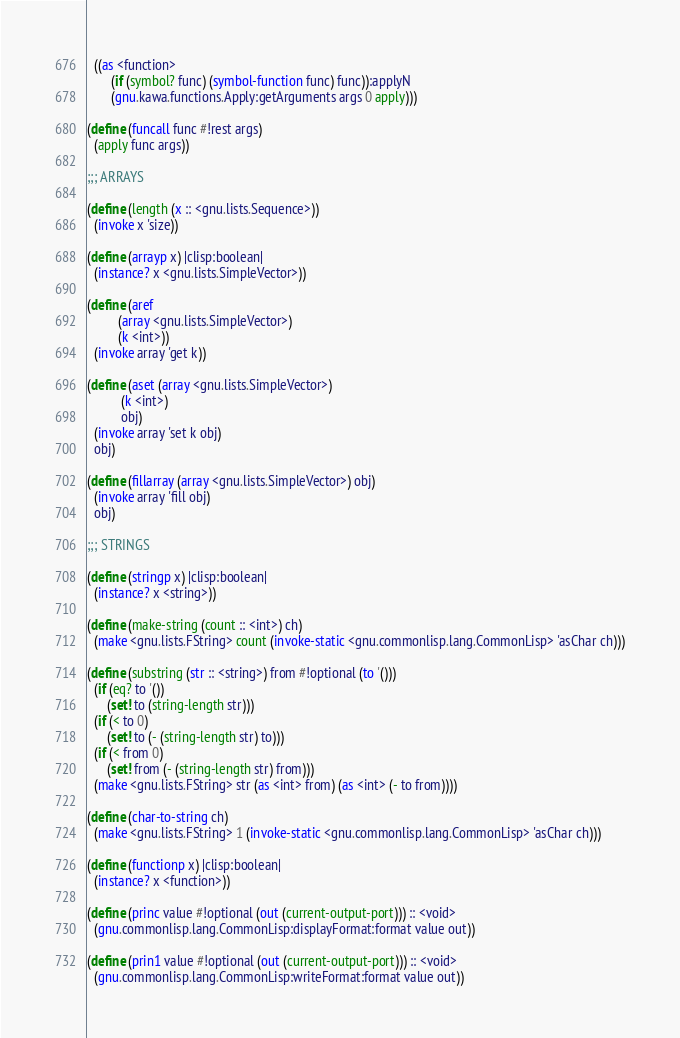<code> <loc_0><loc_0><loc_500><loc_500><_Scheme_>  ((as <function>
       (if (symbol? func) (symbol-function func) func)):applyN
       (gnu.kawa.functions.Apply:getArguments args 0 apply)))

(define (funcall func #!rest args)
  (apply func args))

;;; ARRAYS

(define (length (x :: <gnu.lists.Sequence>))
  (invoke x 'size))

(define (arrayp x) |clisp:boolean|
  (instance? x <gnu.lists.SimpleVector>))

(define (aref
         (array <gnu.lists.SimpleVector>)
         (k <int>))
  (invoke array 'get k))

(define (aset (array <gnu.lists.SimpleVector>)
	      (k <int>)
	      obj)
  (invoke array 'set k obj)
  obj)

(define (fillarray (array <gnu.lists.SimpleVector>) obj)
  (invoke array 'fill obj)
  obj)

;;; STRINGS

(define (stringp x) |clisp:boolean|
  (instance? x <string>))

(define (make-string (count :: <int>) ch)
  (make <gnu.lists.FString> count (invoke-static <gnu.commonlisp.lang.CommonLisp> 'asChar ch)))

(define (substring (str :: <string>) from #!optional (to '()))
  (if (eq? to '())
      (set! to (string-length str)))
  (if (< to 0)
      (set! to (- (string-length str) to)))
  (if (< from 0)
      (set! from (- (string-length str) from)))
  (make <gnu.lists.FString> str (as <int> from) (as <int> (- to from))))

(define (char-to-string ch)
  (make <gnu.lists.FString> 1 (invoke-static <gnu.commonlisp.lang.CommonLisp> 'asChar ch)))

(define (functionp x) |clisp:boolean|
  (instance? x <function>))

(define (princ value #!optional (out (current-output-port))) :: <void>
  (gnu.commonlisp.lang.CommonLisp:displayFormat:format value out))

(define (prin1 value #!optional (out (current-output-port))) :: <void>
  (gnu.commonlisp.lang.CommonLisp:writeFormat:format value out))
</code> 